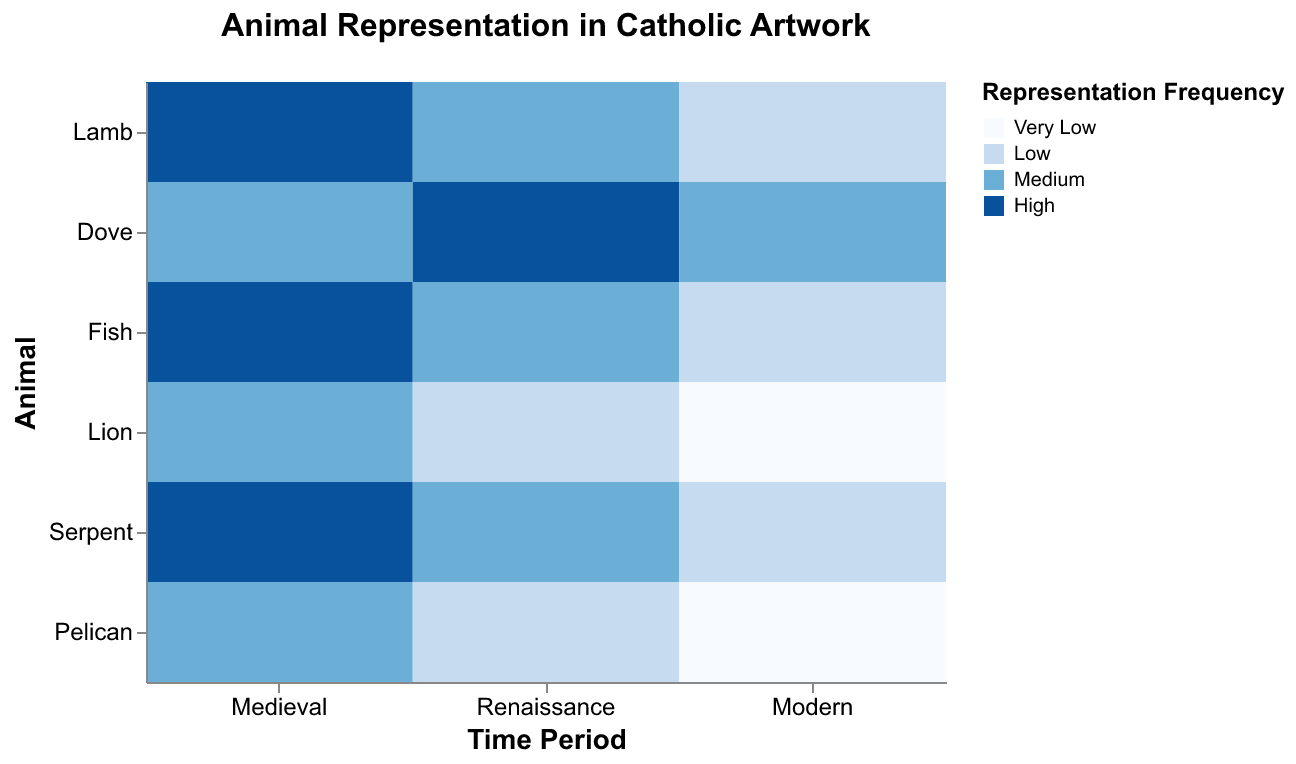What is the title of the figure? The title is located at the top center of the figure and reads "Animal Representation in Catholic Artwork".
Answer: Animal Representation in Catholic Artwork Which animal has the highest representation frequency in the Renaissance period? To find the animal with the highest representation frequency in the Renaissance period, look at the Renaissance column and identify the darkest shade in the color range corresponding to 'High'. The darkest shade corresponds to the Dove.
Answer: Dove How does the representation frequency of the Lion change over time? Examine the color shades for the Lion row across the three time periods. The Medieval period is medium (second darkest), Renaissance is low (second lightest), and Modern is very low (lightest). Therefore, the frequency decreases over time.
Answer: Decreases Which animals have a medium representation frequency in the Medieval period? Find the Medieval column and locate the medium color shade (medium blue). The animals corresponding to the medium blue color are Dove, Lion, and Pelican.
Answer: Dove, Lion, Pelican Compare the representation frequency of the Fish and the Lamb in the Modern period. Which one has higher representation? In the Modern period column, observe the color shades for Fish and Lamb. The Lamb is low (second lightest) and Fish is low (second lightest) as well. So, both have the same representation frequency.
Answer: Same What is the general trend for the Serpent's representation over the time periods? Look at the Serpent row across the time periods. In the Medieval period, it is high (darkest), in the Renaissance it is medium (medium blue), and in the Modern period, it is low (second lightest). This shows a decreasing trend.
Answer: Decreasing Which time period has the most variety in representation frequencies? Check each time period column for the variation in color shades. The Medieval period has high, medium, and low, while the Renaissance has high, medium, and low, and Modern has low and very low. Therefore, Medieval and Renaissance have the most variety.
Answer: Medieval, Renaissance What animals have any representation frequency greater than 'Low' in the Modern time period? Check the Modern period column for colors other than the two lightest shades. Only the Dove has a representation frequency marked as medium (medium blue).
Answer: Dove Which animal's representation frequency never drops below 'Medium' throughout all time periods? Observe each animal row to find if any always has the medium or higher shades (medium blue or darker). The Dove meets this condition.
Answer: Dove 